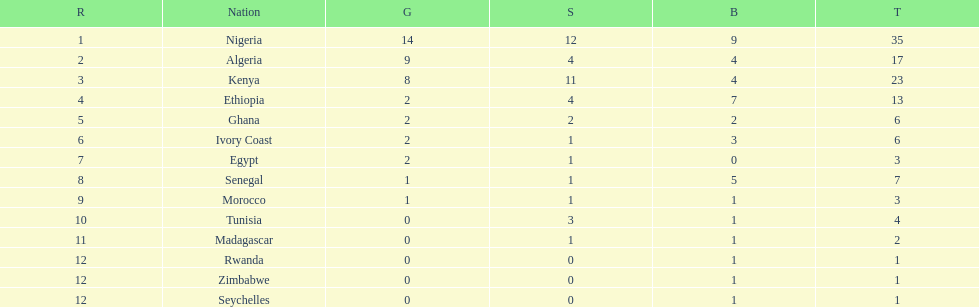How many silver medals did kenya earn? 11. 